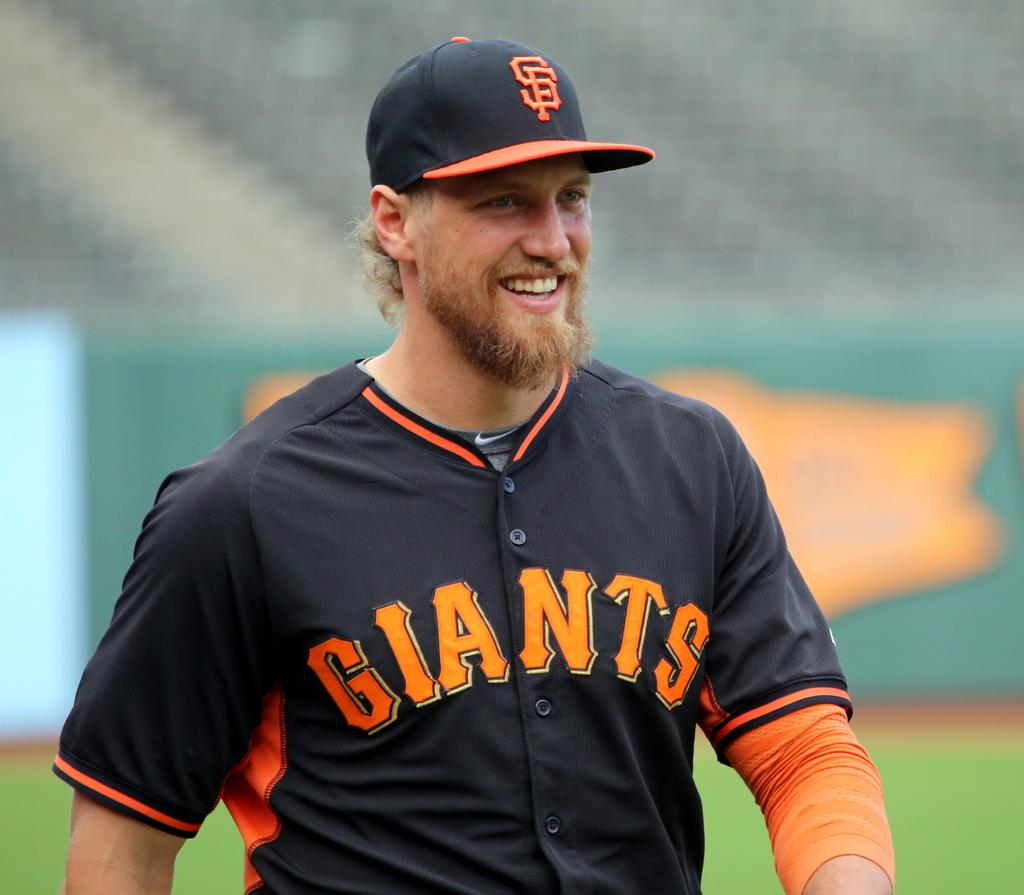<image>
Present a compact description of the photo's key features. san francisco giants player in black and orange jersey smiling 